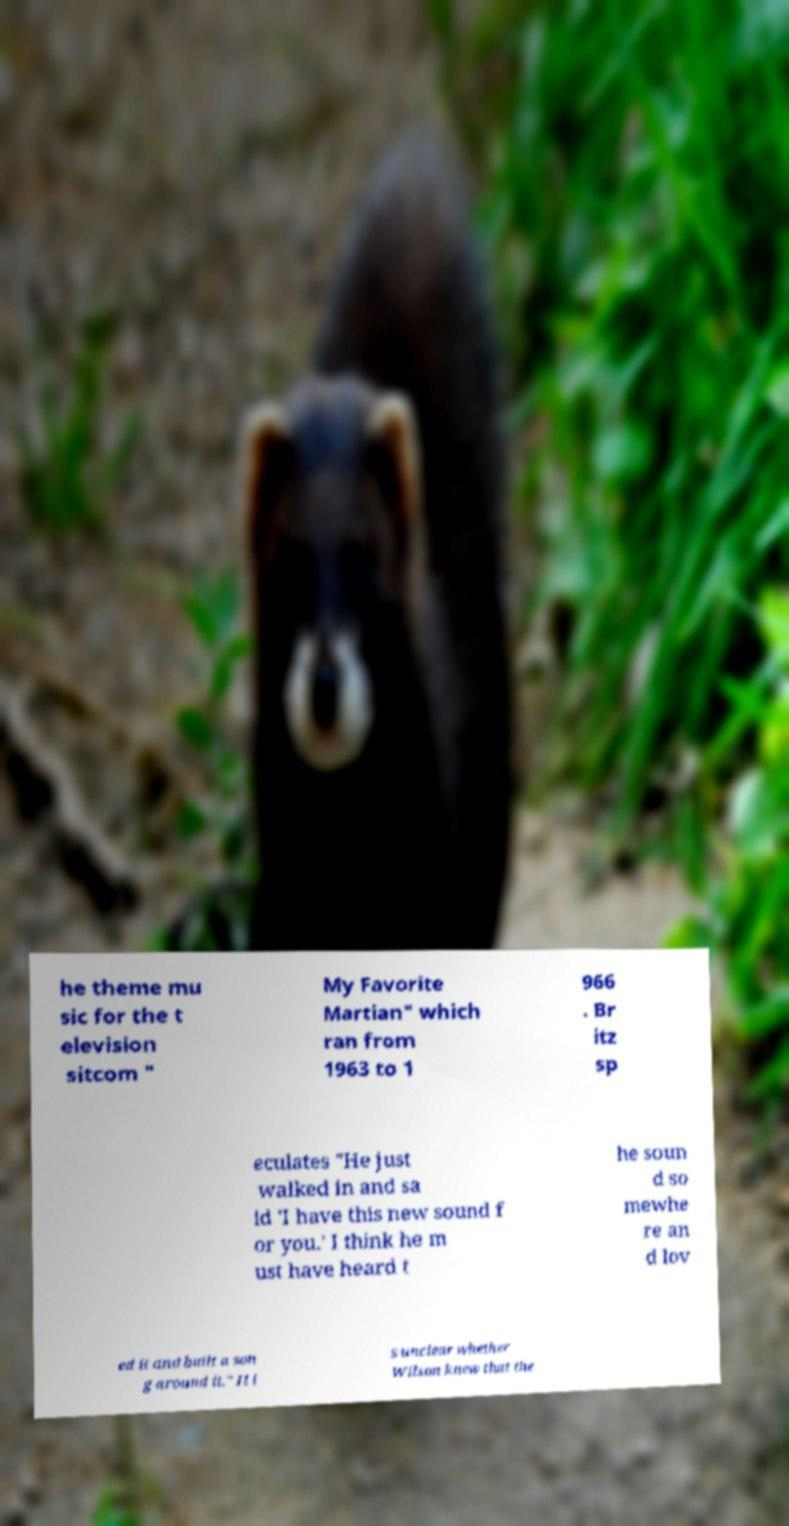I need the written content from this picture converted into text. Can you do that? he theme mu sic for the t elevision sitcom " My Favorite Martian" which ran from 1963 to 1 966 . Br itz sp eculates "He just walked in and sa id 'I have this new sound f or you.' I think he m ust have heard t he soun d so mewhe re an d lov ed it and built a son g around it." It i s unclear whether Wilson knew that the 